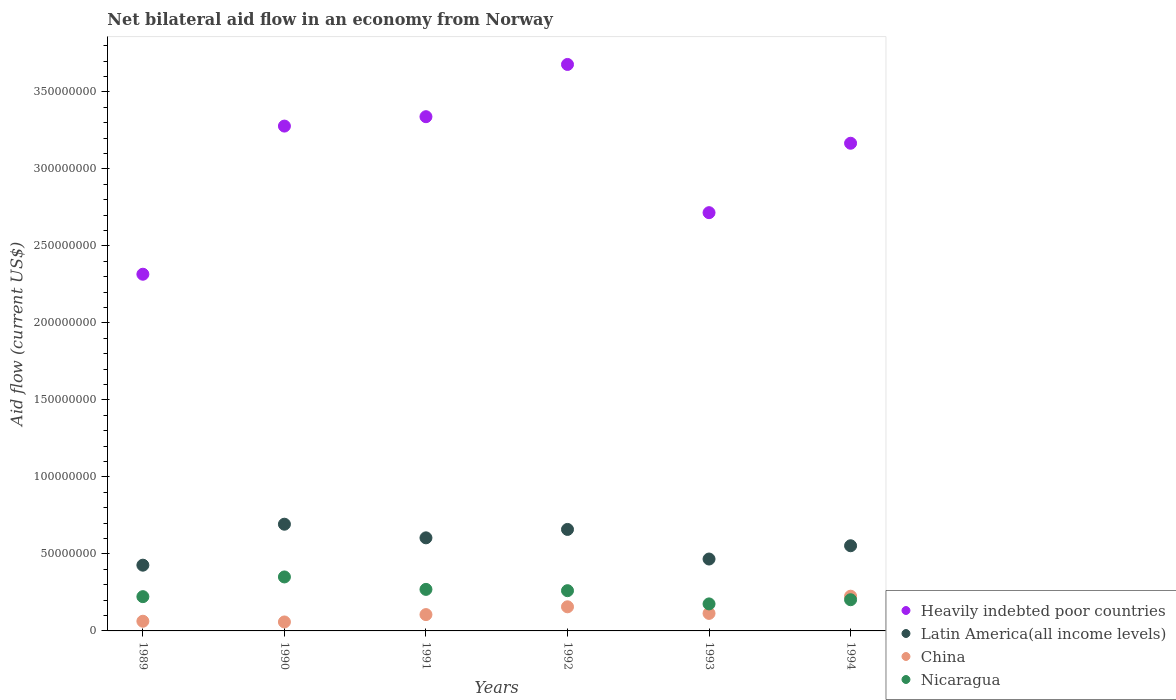Is the number of dotlines equal to the number of legend labels?
Offer a terse response. Yes. What is the net bilateral aid flow in Nicaragua in 1994?
Your answer should be compact. 2.02e+07. Across all years, what is the maximum net bilateral aid flow in Heavily indebted poor countries?
Make the answer very short. 3.68e+08. Across all years, what is the minimum net bilateral aid flow in Nicaragua?
Your answer should be very brief. 1.75e+07. In which year was the net bilateral aid flow in Latin America(all income levels) minimum?
Keep it short and to the point. 1989. What is the total net bilateral aid flow in Latin America(all income levels) in the graph?
Your answer should be compact. 3.40e+08. What is the difference between the net bilateral aid flow in China in 1990 and that in 1992?
Provide a succinct answer. -9.84e+06. What is the difference between the net bilateral aid flow in Heavily indebted poor countries in 1989 and the net bilateral aid flow in China in 1990?
Keep it short and to the point. 2.26e+08. What is the average net bilateral aid flow in China per year?
Make the answer very short. 1.20e+07. In the year 1991, what is the difference between the net bilateral aid flow in Nicaragua and net bilateral aid flow in Latin America(all income levels)?
Give a very brief answer. -3.35e+07. What is the ratio of the net bilateral aid flow in Latin America(all income levels) in 1991 to that in 1994?
Your answer should be compact. 1.09. What is the difference between the highest and the second highest net bilateral aid flow in China?
Offer a very short reply. 6.89e+06. What is the difference between the highest and the lowest net bilateral aid flow in Heavily indebted poor countries?
Ensure brevity in your answer.  1.36e+08. Does the net bilateral aid flow in Nicaragua monotonically increase over the years?
Ensure brevity in your answer.  No. Is the net bilateral aid flow in Heavily indebted poor countries strictly greater than the net bilateral aid flow in China over the years?
Your response must be concise. Yes. Is the net bilateral aid flow in Heavily indebted poor countries strictly less than the net bilateral aid flow in China over the years?
Offer a very short reply. No. How many dotlines are there?
Your answer should be very brief. 4. How many years are there in the graph?
Offer a very short reply. 6. Does the graph contain any zero values?
Provide a short and direct response. No. Does the graph contain grids?
Ensure brevity in your answer.  No. Where does the legend appear in the graph?
Your answer should be compact. Bottom right. How many legend labels are there?
Give a very brief answer. 4. How are the legend labels stacked?
Your answer should be very brief. Vertical. What is the title of the graph?
Provide a short and direct response. Net bilateral aid flow in an economy from Norway. What is the label or title of the X-axis?
Your answer should be very brief. Years. What is the label or title of the Y-axis?
Your answer should be very brief. Aid flow (current US$). What is the Aid flow (current US$) in Heavily indebted poor countries in 1989?
Give a very brief answer. 2.32e+08. What is the Aid flow (current US$) in Latin America(all income levels) in 1989?
Your response must be concise. 4.27e+07. What is the Aid flow (current US$) in China in 1989?
Keep it short and to the point. 6.28e+06. What is the Aid flow (current US$) in Nicaragua in 1989?
Provide a short and direct response. 2.22e+07. What is the Aid flow (current US$) of Heavily indebted poor countries in 1990?
Offer a terse response. 3.28e+08. What is the Aid flow (current US$) of Latin America(all income levels) in 1990?
Offer a terse response. 6.93e+07. What is the Aid flow (current US$) in China in 1990?
Your response must be concise. 5.82e+06. What is the Aid flow (current US$) of Nicaragua in 1990?
Your answer should be very brief. 3.50e+07. What is the Aid flow (current US$) in Heavily indebted poor countries in 1991?
Your answer should be very brief. 3.34e+08. What is the Aid flow (current US$) in Latin America(all income levels) in 1991?
Offer a very short reply. 6.04e+07. What is the Aid flow (current US$) in China in 1991?
Offer a terse response. 1.06e+07. What is the Aid flow (current US$) in Nicaragua in 1991?
Offer a very short reply. 2.70e+07. What is the Aid flow (current US$) of Heavily indebted poor countries in 1992?
Give a very brief answer. 3.68e+08. What is the Aid flow (current US$) of Latin America(all income levels) in 1992?
Offer a very short reply. 6.59e+07. What is the Aid flow (current US$) in China in 1992?
Your answer should be compact. 1.57e+07. What is the Aid flow (current US$) in Nicaragua in 1992?
Your answer should be very brief. 2.61e+07. What is the Aid flow (current US$) in Heavily indebted poor countries in 1993?
Make the answer very short. 2.72e+08. What is the Aid flow (current US$) in Latin America(all income levels) in 1993?
Provide a succinct answer. 4.67e+07. What is the Aid flow (current US$) of China in 1993?
Keep it short and to the point. 1.14e+07. What is the Aid flow (current US$) in Nicaragua in 1993?
Your response must be concise. 1.75e+07. What is the Aid flow (current US$) in Heavily indebted poor countries in 1994?
Offer a very short reply. 3.17e+08. What is the Aid flow (current US$) of Latin America(all income levels) in 1994?
Keep it short and to the point. 5.53e+07. What is the Aid flow (current US$) in China in 1994?
Your answer should be compact. 2.26e+07. What is the Aid flow (current US$) in Nicaragua in 1994?
Make the answer very short. 2.02e+07. Across all years, what is the maximum Aid flow (current US$) of Heavily indebted poor countries?
Provide a short and direct response. 3.68e+08. Across all years, what is the maximum Aid flow (current US$) in Latin America(all income levels)?
Your answer should be very brief. 6.93e+07. Across all years, what is the maximum Aid flow (current US$) of China?
Offer a terse response. 2.26e+07. Across all years, what is the maximum Aid flow (current US$) of Nicaragua?
Your answer should be compact. 3.50e+07. Across all years, what is the minimum Aid flow (current US$) of Heavily indebted poor countries?
Provide a short and direct response. 2.32e+08. Across all years, what is the minimum Aid flow (current US$) of Latin America(all income levels)?
Provide a succinct answer. 4.27e+07. Across all years, what is the minimum Aid flow (current US$) of China?
Keep it short and to the point. 5.82e+06. Across all years, what is the minimum Aid flow (current US$) of Nicaragua?
Offer a terse response. 1.75e+07. What is the total Aid flow (current US$) in Heavily indebted poor countries in the graph?
Give a very brief answer. 1.85e+09. What is the total Aid flow (current US$) of Latin America(all income levels) in the graph?
Your response must be concise. 3.40e+08. What is the total Aid flow (current US$) in China in the graph?
Make the answer very short. 7.23e+07. What is the total Aid flow (current US$) in Nicaragua in the graph?
Your answer should be compact. 1.48e+08. What is the difference between the Aid flow (current US$) of Heavily indebted poor countries in 1989 and that in 1990?
Provide a short and direct response. -9.62e+07. What is the difference between the Aid flow (current US$) of Latin America(all income levels) in 1989 and that in 1990?
Ensure brevity in your answer.  -2.66e+07. What is the difference between the Aid flow (current US$) in Nicaragua in 1989 and that in 1990?
Provide a succinct answer. -1.28e+07. What is the difference between the Aid flow (current US$) of Heavily indebted poor countries in 1989 and that in 1991?
Your answer should be compact. -1.02e+08. What is the difference between the Aid flow (current US$) in Latin America(all income levels) in 1989 and that in 1991?
Provide a short and direct response. -1.78e+07. What is the difference between the Aid flow (current US$) in China in 1989 and that in 1991?
Make the answer very short. -4.32e+06. What is the difference between the Aid flow (current US$) in Nicaragua in 1989 and that in 1991?
Give a very brief answer. -4.72e+06. What is the difference between the Aid flow (current US$) of Heavily indebted poor countries in 1989 and that in 1992?
Make the answer very short. -1.36e+08. What is the difference between the Aid flow (current US$) in Latin America(all income levels) in 1989 and that in 1992?
Your answer should be very brief. -2.32e+07. What is the difference between the Aid flow (current US$) of China in 1989 and that in 1992?
Make the answer very short. -9.38e+06. What is the difference between the Aid flow (current US$) of Nicaragua in 1989 and that in 1992?
Provide a succinct answer. -3.88e+06. What is the difference between the Aid flow (current US$) in Heavily indebted poor countries in 1989 and that in 1993?
Keep it short and to the point. -4.00e+07. What is the difference between the Aid flow (current US$) of Latin America(all income levels) in 1989 and that in 1993?
Your response must be concise. -3.99e+06. What is the difference between the Aid flow (current US$) in China in 1989 and that in 1993?
Your answer should be very brief. -5.09e+06. What is the difference between the Aid flow (current US$) in Nicaragua in 1989 and that in 1993?
Your response must be concise. 4.71e+06. What is the difference between the Aid flow (current US$) in Heavily indebted poor countries in 1989 and that in 1994?
Keep it short and to the point. -8.50e+07. What is the difference between the Aid flow (current US$) of Latin America(all income levels) in 1989 and that in 1994?
Your answer should be very brief. -1.26e+07. What is the difference between the Aid flow (current US$) in China in 1989 and that in 1994?
Your answer should be very brief. -1.63e+07. What is the difference between the Aid flow (current US$) in Heavily indebted poor countries in 1990 and that in 1991?
Ensure brevity in your answer.  -6.10e+06. What is the difference between the Aid flow (current US$) in Latin America(all income levels) in 1990 and that in 1991?
Keep it short and to the point. 8.85e+06. What is the difference between the Aid flow (current US$) in China in 1990 and that in 1991?
Ensure brevity in your answer.  -4.78e+06. What is the difference between the Aid flow (current US$) of Nicaragua in 1990 and that in 1991?
Provide a succinct answer. 8.08e+06. What is the difference between the Aid flow (current US$) of Heavily indebted poor countries in 1990 and that in 1992?
Keep it short and to the point. -4.00e+07. What is the difference between the Aid flow (current US$) of Latin America(all income levels) in 1990 and that in 1992?
Give a very brief answer. 3.39e+06. What is the difference between the Aid flow (current US$) in China in 1990 and that in 1992?
Offer a very short reply. -9.84e+06. What is the difference between the Aid flow (current US$) in Nicaragua in 1990 and that in 1992?
Your response must be concise. 8.92e+06. What is the difference between the Aid flow (current US$) in Heavily indebted poor countries in 1990 and that in 1993?
Give a very brief answer. 5.62e+07. What is the difference between the Aid flow (current US$) of Latin America(all income levels) in 1990 and that in 1993?
Your answer should be compact. 2.26e+07. What is the difference between the Aid flow (current US$) in China in 1990 and that in 1993?
Make the answer very short. -5.55e+06. What is the difference between the Aid flow (current US$) in Nicaragua in 1990 and that in 1993?
Make the answer very short. 1.75e+07. What is the difference between the Aid flow (current US$) of Heavily indebted poor countries in 1990 and that in 1994?
Provide a short and direct response. 1.11e+07. What is the difference between the Aid flow (current US$) of Latin America(all income levels) in 1990 and that in 1994?
Provide a succinct answer. 1.40e+07. What is the difference between the Aid flow (current US$) in China in 1990 and that in 1994?
Keep it short and to the point. -1.67e+07. What is the difference between the Aid flow (current US$) of Nicaragua in 1990 and that in 1994?
Give a very brief answer. 1.48e+07. What is the difference between the Aid flow (current US$) of Heavily indebted poor countries in 1991 and that in 1992?
Your answer should be very brief. -3.39e+07. What is the difference between the Aid flow (current US$) in Latin America(all income levels) in 1991 and that in 1992?
Your answer should be compact. -5.46e+06. What is the difference between the Aid flow (current US$) of China in 1991 and that in 1992?
Provide a short and direct response. -5.06e+06. What is the difference between the Aid flow (current US$) in Nicaragua in 1991 and that in 1992?
Your response must be concise. 8.40e+05. What is the difference between the Aid flow (current US$) in Heavily indebted poor countries in 1991 and that in 1993?
Your answer should be very brief. 6.23e+07. What is the difference between the Aid flow (current US$) of Latin America(all income levels) in 1991 and that in 1993?
Provide a short and direct response. 1.38e+07. What is the difference between the Aid flow (current US$) in China in 1991 and that in 1993?
Provide a succinct answer. -7.70e+05. What is the difference between the Aid flow (current US$) in Nicaragua in 1991 and that in 1993?
Make the answer very short. 9.43e+06. What is the difference between the Aid flow (current US$) of Heavily indebted poor countries in 1991 and that in 1994?
Your response must be concise. 1.72e+07. What is the difference between the Aid flow (current US$) of Latin America(all income levels) in 1991 and that in 1994?
Ensure brevity in your answer.  5.14e+06. What is the difference between the Aid flow (current US$) of China in 1991 and that in 1994?
Your answer should be very brief. -1.20e+07. What is the difference between the Aid flow (current US$) of Nicaragua in 1991 and that in 1994?
Give a very brief answer. 6.72e+06. What is the difference between the Aid flow (current US$) in Heavily indebted poor countries in 1992 and that in 1993?
Provide a short and direct response. 9.62e+07. What is the difference between the Aid flow (current US$) in Latin America(all income levels) in 1992 and that in 1993?
Ensure brevity in your answer.  1.92e+07. What is the difference between the Aid flow (current US$) of China in 1992 and that in 1993?
Provide a short and direct response. 4.29e+06. What is the difference between the Aid flow (current US$) in Nicaragua in 1992 and that in 1993?
Offer a very short reply. 8.59e+06. What is the difference between the Aid flow (current US$) in Heavily indebted poor countries in 1992 and that in 1994?
Your answer should be very brief. 5.12e+07. What is the difference between the Aid flow (current US$) of Latin America(all income levels) in 1992 and that in 1994?
Offer a terse response. 1.06e+07. What is the difference between the Aid flow (current US$) in China in 1992 and that in 1994?
Offer a terse response. -6.89e+06. What is the difference between the Aid flow (current US$) of Nicaragua in 1992 and that in 1994?
Your response must be concise. 5.88e+06. What is the difference between the Aid flow (current US$) of Heavily indebted poor countries in 1993 and that in 1994?
Your answer should be compact. -4.51e+07. What is the difference between the Aid flow (current US$) in Latin America(all income levels) in 1993 and that in 1994?
Provide a short and direct response. -8.62e+06. What is the difference between the Aid flow (current US$) of China in 1993 and that in 1994?
Ensure brevity in your answer.  -1.12e+07. What is the difference between the Aid flow (current US$) of Nicaragua in 1993 and that in 1994?
Offer a terse response. -2.71e+06. What is the difference between the Aid flow (current US$) of Heavily indebted poor countries in 1989 and the Aid flow (current US$) of Latin America(all income levels) in 1990?
Make the answer very short. 1.62e+08. What is the difference between the Aid flow (current US$) in Heavily indebted poor countries in 1989 and the Aid flow (current US$) in China in 1990?
Your answer should be very brief. 2.26e+08. What is the difference between the Aid flow (current US$) in Heavily indebted poor countries in 1989 and the Aid flow (current US$) in Nicaragua in 1990?
Provide a short and direct response. 1.97e+08. What is the difference between the Aid flow (current US$) of Latin America(all income levels) in 1989 and the Aid flow (current US$) of China in 1990?
Keep it short and to the point. 3.69e+07. What is the difference between the Aid flow (current US$) of Latin America(all income levels) in 1989 and the Aid flow (current US$) of Nicaragua in 1990?
Your answer should be compact. 7.64e+06. What is the difference between the Aid flow (current US$) in China in 1989 and the Aid flow (current US$) in Nicaragua in 1990?
Your response must be concise. -2.88e+07. What is the difference between the Aid flow (current US$) of Heavily indebted poor countries in 1989 and the Aid flow (current US$) of Latin America(all income levels) in 1991?
Your answer should be compact. 1.71e+08. What is the difference between the Aid flow (current US$) of Heavily indebted poor countries in 1989 and the Aid flow (current US$) of China in 1991?
Provide a short and direct response. 2.21e+08. What is the difference between the Aid flow (current US$) in Heavily indebted poor countries in 1989 and the Aid flow (current US$) in Nicaragua in 1991?
Provide a succinct answer. 2.05e+08. What is the difference between the Aid flow (current US$) in Latin America(all income levels) in 1989 and the Aid flow (current US$) in China in 1991?
Offer a terse response. 3.21e+07. What is the difference between the Aid flow (current US$) of Latin America(all income levels) in 1989 and the Aid flow (current US$) of Nicaragua in 1991?
Offer a terse response. 1.57e+07. What is the difference between the Aid flow (current US$) in China in 1989 and the Aid flow (current US$) in Nicaragua in 1991?
Provide a succinct answer. -2.07e+07. What is the difference between the Aid flow (current US$) in Heavily indebted poor countries in 1989 and the Aid flow (current US$) in Latin America(all income levels) in 1992?
Provide a succinct answer. 1.66e+08. What is the difference between the Aid flow (current US$) of Heavily indebted poor countries in 1989 and the Aid flow (current US$) of China in 1992?
Provide a succinct answer. 2.16e+08. What is the difference between the Aid flow (current US$) of Heavily indebted poor countries in 1989 and the Aid flow (current US$) of Nicaragua in 1992?
Your response must be concise. 2.05e+08. What is the difference between the Aid flow (current US$) of Latin America(all income levels) in 1989 and the Aid flow (current US$) of China in 1992?
Offer a terse response. 2.70e+07. What is the difference between the Aid flow (current US$) in Latin America(all income levels) in 1989 and the Aid flow (current US$) in Nicaragua in 1992?
Offer a very short reply. 1.66e+07. What is the difference between the Aid flow (current US$) of China in 1989 and the Aid flow (current US$) of Nicaragua in 1992?
Provide a short and direct response. -1.98e+07. What is the difference between the Aid flow (current US$) of Heavily indebted poor countries in 1989 and the Aid flow (current US$) of Latin America(all income levels) in 1993?
Your answer should be compact. 1.85e+08. What is the difference between the Aid flow (current US$) in Heavily indebted poor countries in 1989 and the Aid flow (current US$) in China in 1993?
Offer a very short reply. 2.20e+08. What is the difference between the Aid flow (current US$) in Heavily indebted poor countries in 1989 and the Aid flow (current US$) in Nicaragua in 1993?
Give a very brief answer. 2.14e+08. What is the difference between the Aid flow (current US$) of Latin America(all income levels) in 1989 and the Aid flow (current US$) of China in 1993?
Ensure brevity in your answer.  3.13e+07. What is the difference between the Aid flow (current US$) of Latin America(all income levels) in 1989 and the Aid flow (current US$) of Nicaragua in 1993?
Ensure brevity in your answer.  2.52e+07. What is the difference between the Aid flow (current US$) of China in 1989 and the Aid flow (current US$) of Nicaragua in 1993?
Your answer should be compact. -1.13e+07. What is the difference between the Aid flow (current US$) of Heavily indebted poor countries in 1989 and the Aid flow (current US$) of Latin America(all income levels) in 1994?
Keep it short and to the point. 1.76e+08. What is the difference between the Aid flow (current US$) in Heavily indebted poor countries in 1989 and the Aid flow (current US$) in China in 1994?
Keep it short and to the point. 2.09e+08. What is the difference between the Aid flow (current US$) of Heavily indebted poor countries in 1989 and the Aid flow (current US$) of Nicaragua in 1994?
Offer a terse response. 2.11e+08. What is the difference between the Aid flow (current US$) of Latin America(all income levels) in 1989 and the Aid flow (current US$) of China in 1994?
Keep it short and to the point. 2.01e+07. What is the difference between the Aid flow (current US$) in Latin America(all income levels) in 1989 and the Aid flow (current US$) in Nicaragua in 1994?
Give a very brief answer. 2.24e+07. What is the difference between the Aid flow (current US$) in China in 1989 and the Aid flow (current US$) in Nicaragua in 1994?
Keep it short and to the point. -1.40e+07. What is the difference between the Aid flow (current US$) of Heavily indebted poor countries in 1990 and the Aid flow (current US$) of Latin America(all income levels) in 1991?
Offer a very short reply. 2.67e+08. What is the difference between the Aid flow (current US$) in Heavily indebted poor countries in 1990 and the Aid flow (current US$) in China in 1991?
Offer a terse response. 3.17e+08. What is the difference between the Aid flow (current US$) of Heavily indebted poor countries in 1990 and the Aid flow (current US$) of Nicaragua in 1991?
Your answer should be very brief. 3.01e+08. What is the difference between the Aid flow (current US$) of Latin America(all income levels) in 1990 and the Aid flow (current US$) of China in 1991?
Keep it short and to the point. 5.87e+07. What is the difference between the Aid flow (current US$) in Latin America(all income levels) in 1990 and the Aid flow (current US$) in Nicaragua in 1991?
Your response must be concise. 4.23e+07. What is the difference between the Aid flow (current US$) of China in 1990 and the Aid flow (current US$) of Nicaragua in 1991?
Provide a succinct answer. -2.12e+07. What is the difference between the Aid flow (current US$) in Heavily indebted poor countries in 1990 and the Aid flow (current US$) in Latin America(all income levels) in 1992?
Your response must be concise. 2.62e+08. What is the difference between the Aid flow (current US$) of Heavily indebted poor countries in 1990 and the Aid flow (current US$) of China in 1992?
Provide a short and direct response. 3.12e+08. What is the difference between the Aid flow (current US$) in Heavily indebted poor countries in 1990 and the Aid flow (current US$) in Nicaragua in 1992?
Your response must be concise. 3.02e+08. What is the difference between the Aid flow (current US$) in Latin America(all income levels) in 1990 and the Aid flow (current US$) in China in 1992?
Provide a short and direct response. 5.36e+07. What is the difference between the Aid flow (current US$) of Latin America(all income levels) in 1990 and the Aid flow (current US$) of Nicaragua in 1992?
Give a very brief answer. 4.32e+07. What is the difference between the Aid flow (current US$) in China in 1990 and the Aid flow (current US$) in Nicaragua in 1992?
Ensure brevity in your answer.  -2.03e+07. What is the difference between the Aid flow (current US$) in Heavily indebted poor countries in 1990 and the Aid flow (current US$) in Latin America(all income levels) in 1993?
Your answer should be compact. 2.81e+08. What is the difference between the Aid flow (current US$) of Heavily indebted poor countries in 1990 and the Aid flow (current US$) of China in 1993?
Keep it short and to the point. 3.16e+08. What is the difference between the Aid flow (current US$) of Heavily indebted poor countries in 1990 and the Aid flow (current US$) of Nicaragua in 1993?
Give a very brief answer. 3.10e+08. What is the difference between the Aid flow (current US$) of Latin America(all income levels) in 1990 and the Aid flow (current US$) of China in 1993?
Give a very brief answer. 5.79e+07. What is the difference between the Aid flow (current US$) of Latin America(all income levels) in 1990 and the Aid flow (current US$) of Nicaragua in 1993?
Make the answer very short. 5.18e+07. What is the difference between the Aid flow (current US$) of China in 1990 and the Aid flow (current US$) of Nicaragua in 1993?
Provide a succinct answer. -1.17e+07. What is the difference between the Aid flow (current US$) of Heavily indebted poor countries in 1990 and the Aid flow (current US$) of Latin America(all income levels) in 1994?
Offer a terse response. 2.72e+08. What is the difference between the Aid flow (current US$) in Heavily indebted poor countries in 1990 and the Aid flow (current US$) in China in 1994?
Provide a succinct answer. 3.05e+08. What is the difference between the Aid flow (current US$) of Heavily indebted poor countries in 1990 and the Aid flow (current US$) of Nicaragua in 1994?
Offer a terse response. 3.08e+08. What is the difference between the Aid flow (current US$) in Latin America(all income levels) in 1990 and the Aid flow (current US$) in China in 1994?
Ensure brevity in your answer.  4.67e+07. What is the difference between the Aid flow (current US$) in Latin America(all income levels) in 1990 and the Aid flow (current US$) in Nicaragua in 1994?
Your answer should be compact. 4.90e+07. What is the difference between the Aid flow (current US$) in China in 1990 and the Aid flow (current US$) in Nicaragua in 1994?
Your answer should be very brief. -1.44e+07. What is the difference between the Aid flow (current US$) of Heavily indebted poor countries in 1991 and the Aid flow (current US$) of Latin America(all income levels) in 1992?
Keep it short and to the point. 2.68e+08. What is the difference between the Aid flow (current US$) of Heavily indebted poor countries in 1991 and the Aid flow (current US$) of China in 1992?
Ensure brevity in your answer.  3.18e+08. What is the difference between the Aid flow (current US$) of Heavily indebted poor countries in 1991 and the Aid flow (current US$) of Nicaragua in 1992?
Offer a terse response. 3.08e+08. What is the difference between the Aid flow (current US$) in Latin America(all income levels) in 1991 and the Aid flow (current US$) in China in 1992?
Make the answer very short. 4.48e+07. What is the difference between the Aid flow (current US$) in Latin America(all income levels) in 1991 and the Aid flow (current US$) in Nicaragua in 1992?
Your answer should be very brief. 3.43e+07. What is the difference between the Aid flow (current US$) in China in 1991 and the Aid flow (current US$) in Nicaragua in 1992?
Your response must be concise. -1.55e+07. What is the difference between the Aid flow (current US$) of Heavily indebted poor countries in 1991 and the Aid flow (current US$) of Latin America(all income levels) in 1993?
Offer a terse response. 2.87e+08. What is the difference between the Aid flow (current US$) of Heavily indebted poor countries in 1991 and the Aid flow (current US$) of China in 1993?
Offer a terse response. 3.23e+08. What is the difference between the Aid flow (current US$) of Heavily indebted poor countries in 1991 and the Aid flow (current US$) of Nicaragua in 1993?
Provide a short and direct response. 3.16e+08. What is the difference between the Aid flow (current US$) in Latin America(all income levels) in 1991 and the Aid flow (current US$) in China in 1993?
Keep it short and to the point. 4.91e+07. What is the difference between the Aid flow (current US$) in Latin America(all income levels) in 1991 and the Aid flow (current US$) in Nicaragua in 1993?
Your response must be concise. 4.29e+07. What is the difference between the Aid flow (current US$) of China in 1991 and the Aid flow (current US$) of Nicaragua in 1993?
Keep it short and to the point. -6.94e+06. What is the difference between the Aid flow (current US$) of Heavily indebted poor countries in 1991 and the Aid flow (current US$) of Latin America(all income levels) in 1994?
Make the answer very short. 2.79e+08. What is the difference between the Aid flow (current US$) in Heavily indebted poor countries in 1991 and the Aid flow (current US$) in China in 1994?
Your answer should be very brief. 3.11e+08. What is the difference between the Aid flow (current US$) in Heavily indebted poor countries in 1991 and the Aid flow (current US$) in Nicaragua in 1994?
Provide a succinct answer. 3.14e+08. What is the difference between the Aid flow (current US$) in Latin America(all income levels) in 1991 and the Aid flow (current US$) in China in 1994?
Your answer should be compact. 3.79e+07. What is the difference between the Aid flow (current US$) of Latin America(all income levels) in 1991 and the Aid flow (current US$) of Nicaragua in 1994?
Make the answer very short. 4.02e+07. What is the difference between the Aid flow (current US$) of China in 1991 and the Aid flow (current US$) of Nicaragua in 1994?
Your response must be concise. -9.65e+06. What is the difference between the Aid flow (current US$) of Heavily indebted poor countries in 1992 and the Aid flow (current US$) of Latin America(all income levels) in 1993?
Offer a very short reply. 3.21e+08. What is the difference between the Aid flow (current US$) in Heavily indebted poor countries in 1992 and the Aid flow (current US$) in China in 1993?
Provide a succinct answer. 3.56e+08. What is the difference between the Aid flow (current US$) in Heavily indebted poor countries in 1992 and the Aid flow (current US$) in Nicaragua in 1993?
Keep it short and to the point. 3.50e+08. What is the difference between the Aid flow (current US$) of Latin America(all income levels) in 1992 and the Aid flow (current US$) of China in 1993?
Your answer should be compact. 5.45e+07. What is the difference between the Aid flow (current US$) in Latin America(all income levels) in 1992 and the Aid flow (current US$) in Nicaragua in 1993?
Your answer should be compact. 4.84e+07. What is the difference between the Aid flow (current US$) of China in 1992 and the Aid flow (current US$) of Nicaragua in 1993?
Offer a terse response. -1.88e+06. What is the difference between the Aid flow (current US$) in Heavily indebted poor countries in 1992 and the Aid flow (current US$) in Latin America(all income levels) in 1994?
Make the answer very short. 3.13e+08. What is the difference between the Aid flow (current US$) of Heavily indebted poor countries in 1992 and the Aid flow (current US$) of China in 1994?
Make the answer very short. 3.45e+08. What is the difference between the Aid flow (current US$) in Heavily indebted poor countries in 1992 and the Aid flow (current US$) in Nicaragua in 1994?
Offer a terse response. 3.48e+08. What is the difference between the Aid flow (current US$) in Latin America(all income levels) in 1992 and the Aid flow (current US$) in China in 1994?
Ensure brevity in your answer.  4.34e+07. What is the difference between the Aid flow (current US$) in Latin America(all income levels) in 1992 and the Aid flow (current US$) in Nicaragua in 1994?
Offer a very short reply. 4.56e+07. What is the difference between the Aid flow (current US$) of China in 1992 and the Aid flow (current US$) of Nicaragua in 1994?
Provide a succinct answer. -4.59e+06. What is the difference between the Aid flow (current US$) of Heavily indebted poor countries in 1993 and the Aid flow (current US$) of Latin America(all income levels) in 1994?
Make the answer very short. 2.16e+08. What is the difference between the Aid flow (current US$) of Heavily indebted poor countries in 1993 and the Aid flow (current US$) of China in 1994?
Give a very brief answer. 2.49e+08. What is the difference between the Aid flow (current US$) of Heavily indebted poor countries in 1993 and the Aid flow (current US$) of Nicaragua in 1994?
Give a very brief answer. 2.51e+08. What is the difference between the Aid flow (current US$) of Latin America(all income levels) in 1993 and the Aid flow (current US$) of China in 1994?
Provide a short and direct response. 2.41e+07. What is the difference between the Aid flow (current US$) of Latin America(all income levels) in 1993 and the Aid flow (current US$) of Nicaragua in 1994?
Provide a succinct answer. 2.64e+07. What is the difference between the Aid flow (current US$) of China in 1993 and the Aid flow (current US$) of Nicaragua in 1994?
Provide a succinct answer. -8.88e+06. What is the average Aid flow (current US$) in Heavily indebted poor countries per year?
Your response must be concise. 3.08e+08. What is the average Aid flow (current US$) in Latin America(all income levels) per year?
Give a very brief answer. 5.67e+07. What is the average Aid flow (current US$) of China per year?
Keep it short and to the point. 1.20e+07. What is the average Aid flow (current US$) of Nicaragua per year?
Offer a very short reply. 2.47e+07. In the year 1989, what is the difference between the Aid flow (current US$) in Heavily indebted poor countries and Aid flow (current US$) in Latin America(all income levels)?
Keep it short and to the point. 1.89e+08. In the year 1989, what is the difference between the Aid flow (current US$) in Heavily indebted poor countries and Aid flow (current US$) in China?
Provide a succinct answer. 2.25e+08. In the year 1989, what is the difference between the Aid flow (current US$) of Heavily indebted poor countries and Aid flow (current US$) of Nicaragua?
Your response must be concise. 2.09e+08. In the year 1989, what is the difference between the Aid flow (current US$) of Latin America(all income levels) and Aid flow (current US$) of China?
Your answer should be compact. 3.64e+07. In the year 1989, what is the difference between the Aid flow (current US$) in Latin America(all income levels) and Aid flow (current US$) in Nicaragua?
Offer a terse response. 2.04e+07. In the year 1989, what is the difference between the Aid flow (current US$) in China and Aid flow (current US$) in Nicaragua?
Provide a short and direct response. -1.60e+07. In the year 1990, what is the difference between the Aid flow (current US$) of Heavily indebted poor countries and Aid flow (current US$) of Latin America(all income levels)?
Offer a terse response. 2.58e+08. In the year 1990, what is the difference between the Aid flow (current US$) of Heavily indebted poor countries and Aid flow (current US$) of China?
Your response must be concise. 3.22e+08. In the year 1990, what is the difference between the Aid flow (current US$) of Heavily indebted poor countries and Aid flow (current US$) of Nicaragua?
Keep it short and to the point. 2.93e+08. In the year 1990, what is the difference between the Aid flow (current US$) of Latin America(all income levels) and Aid flow (current US$) of China?
Your answer should be very brief. 6.35e+07. In the year 1990, what is the difference between the Aid flow (current US$) in Latin America(all income levels) and Aid flow (current US$) in Nicaragua?
Your answer should be compact. 3.42e+07. In the year 1990, what is the difference between the Aid flow (current US$) of China and Aid flow (current US$) of Nicaragua?
Provide a succinct answer. -2.92e+07. In the year 1991, what is the difference between the Aid flow (current US$) of Heavily indebted poor countries and Aid flow (current US$) of Latin America(all income levels)?
Make the answer very short. 2.73e+08. In the year 1991, what is the difference between the Aid flow (current US$) in Heavily indebted poor countries and Aid flow (current US$) in China?
Your answer should be very brief. 3.23e+08. In the year 1991, what is the difference between the Aid flow (current US$) of Heavily indebted poor countries and Aid flow (current US$) of Nicaragua?
Ensure brevity in your answer.  3.07e+08. In the year 1991, what is the difference between the Aid flow (current US$) in Latin America(all income levels) and Aid flow (current US$) in China?
Your response must be concise. 4.98e+07. In the year 1991, what is the difference between the Aid flow (current US$) of Latin America(all income levels) and Aid flow (current US$) of Nicaragua?
Keep it short and to the point. 3.35e+07. In the year 1991, what is the difference between the Aid flow (current US$) of China and Aid flow (current US$) of Nicaragua?
Offer a very short reply. -1.64e+07. In the year 1992, what is the difference between the Aid flow (current US$) in Heavily indebted poor countries and Aid flow (current US$) in Latin America(all income levels)?
Make the answer very short. 3.02e+08. In the year 1992, what is the difference between the Aid flow (current US$) in Heavily indebted poor countries and Aid flow (current US$) in China?
Provide a succinct answer. 3.52e+08. In the year 1992, what is the difference between the Aid flow (current US$) of Heavily indebted poor countries and Aid flow (current US$) of Nicaragua?
Ensure brevity in your answer.  3.42e+08. In the year 1992, what is the difference between the Aid flow (current US$) of Latin America(all income levels) and Aid flow (current US$) of China?
Keep it short and to the point. 5.02e+07. In the year 1992, what is the difference between the Aid flow (current US$) of Latin America(all income levels) and Aid flow (current US$) of Nicaragua?
Provide a short and direct response. 3.98e+07. In the year 1992, what is the difference between the Aid flow (current US$) of China and Aid flow (current US$) of Nicaragua?
Ensure brevity in your answer.  -1.05e+07. In the year 1993, what is the difference between the Aid flow (current US$) in Heavily indebted poor countries and Aid flow (current US$) in Latin America(all income levels)?
Make the answer very short. 2.25e+08. In the year 1993, what is the difference between the Aid flow (current US$) of Heavily indebted poor countries and Aid flow (current US$) of China?
Ensure brevity in your answer.  2.60e+08. In the year 1993, what is the difference between the Aid flow (current US$) of Heavily indebted poor countries and Aid flow (current US$) of Nicaragua?
Your response must be concise. 2.54e+08. In the year 1993, what is the difference between the Aid flow (current US$) in Latin America(all income levels) and Aid flow (current US$) in China?
Provide a succinct answer. 3.53e+07. In the year 1993, what is the difference between the Aid flow (current US$) of Latin America(all income levels) and Aid flow (current US$) of Nicaragua?
Your answer should be compact. 2.91e+07. In the year 1993, what is the difference between the Aid flow (current US$) in China and Aid flow (current US$) in Nicaragua?
Your answer should be very brief. -6.17e+06. In the year 1994, what is the difference between the Aid flow (current US$) in Heavily indebted poor countries and Aid flow (current US$) in Latin America(all income levels)?
Keep it short and to the point. 2.61e+08. In the year 1994, what is the difference between the Aid flow (current US$) in Heavily indebted poor countries and Aid flow (current US$) in China?
Offer a very short reply. 2.94e+08. In the year 1994, what is the difference between the Aid flow (current US$) in Heavily indebted poor countries and Aid flow (current US$) in Nicaragua?
Offer a very short reply. 2.96e+08. In the year 1994, what is the difference between the Aid flow (current US$) of Latin America(all income levels) and Aid flow (current US$) of China?
Offer a very short reply. 3.28e+07. In the year 1994, what is the difference between the Aid flow (current US$) of Latin America(all income levels) and Aid flow (current US$) of Nicaragua?
Offer a terse response. 3.50e+07. In the year 1994, what is the difference between the Aid flow (current US$) of China and Aid flow (current US$) of Nicaragua?
Ensure brevity in your answer.  2.30e+06. What is the ratio of the Aid flow (current US$) in Heavily indebted poor countries in 1989 to that in 1990?
Provide a succinct answer. 0.71. What is the ratio of the Aid flow (current US$) in Latin America(all income levels) in 1989 to that in 1990?
Provide a short and direct response. 0.62. What is the ratio of the Aid flow (current US$) in China in 1989 to that in 1990?
Provide a succinct answer. 1.08. What is the ratio of the Aid flow (current US$) of Nicaragua in 1989 to that in 1990?
Your response must be concise. 0.63. What is the ratio of the Aid flow (current US$) of Heavily indebted poor countries in 1989 to that in 1991?
Provide a short and direct response. 0.69. What is the ratio of the Aid flow (current US$) in Latin America(all income levels) in 1989 to that in 1991?
Ensure brevity in your answer.  0.71. What is the ratio of the Aid flow (current US$) in China in 1989 to that in 1991?
Your answer should be compact. 0.59. What is the ratio of the Aid flow (current US$) of Nicaragua in 1989 to that in 1991?
Offer a very short reply. 0.82. What is the ratio of the Aid flow (current US$) of Heavily indebted poor countries in 1989 to that in 1992?
Offer a very short reply. 0.63. What is the ratio of the Aid flow (current US$) of Latin America(all income levels) in 1989 to that in 1992?
Make the answer very short. 0.65. What is the ratio of the Aid flow (current US$) of China in 1989 to that in 1992?
Make the answer very short. 0.4. What is the ratio of the Aid flow (current US$) in Nicaragua in 1989 to that in 1992?
Provide a succinct answer. 0.85. What is the ratio of the Aid flow (current US$) in Heavily indebted poor countries in 1989 to that in 1993?
Your response must be concise. 0.85. What is the ratio of the Aid flow (current US$) of Latin America(all income levels) in 1989 to that in 1993?
Ensure brevity in your answer.  0.91. What is the ratio of the Aid flow (current US$) in China in 1989 to that in 1993?
Offer a very short reply. 0.55. What is the ratio of the Aid flow (current US$) in Nicaragua in 1989 to that in 1993?
Your answer should be compact. 1.27. What is the ratio of the Aid flow (current US$) in Heavily indebted poor countries in 1989 to that in 1994?
Provide a succinct answer. 0.73. What is the ratio of the Aid flow (current US$) in Latin America(all income levels) in 1989 to that in 1994?
Offer a very short reply. 0.77. What is the ratio of the Aid flow (current US$) of China in 1989 to that in 1994?
Offer a terse response. 0.28. What is the ratio of the Aid flow (current US$) in Nicaragua in 1989 to that in 1994?
Provide a succinct answer. 1.1. What is the ratio of the Aid flow (current US$) of Heavily indebted poor countries in 1990 to that in 1991?
Offer a terse response. 0.98. What is the ratio of the Aid flow (current US$) of Latin America(all income levels) in 1990 to that in 1991?
Your response must be concise. 1.15. What is the ratio of the Aid flow (current US$) in China in 1990 to that in 1991?
Make the answer very short. 0.55. What is the ratio of the Aid flow (current US$) in Nicaragua in 1990 to that in 1991?
Offer a terse response. 1.3. What is the ratio of the Aid flow (current US$) of Heavily indebted poor countries in 1990 to that in 1992?
Provide a short and direct response. 0.89. What is the ratio of the Aid flow (current US$) in Latin America(all income levels) in 1990 to that in 1992?
Offer a very short reply. 1.05. What is the ratio of the Aid flow (current US$) in China in 1990 to that in 1992?
Ensure brevity in your answer.  0.37. What is the ratio of the Aid flow (current US$) of Nicaragua in 1990 to that in 1992?
Ensure brevity in your answer.  1.34. What is the ratio of the Aid flow (current US$) of Heavily indebted poor countries in 1990 to that in 1993?
Provide a short and direct response. 1.21. What is the ratio of the Aid flow (current US$) of Latin America(all income levels) in 1990 to that in 1993?
Keep it short and to the point. 1.48. What is the ratio of the Aid flow (current US$) in China in 1990 to that in 1993?
Offer a very short reply. 0.51. What is the ratio of the Aid flow (current US$) of Nicaragua in 1990 to that in 1993?
Keep it short and to the point. 2. What is the ratio of the Aid flow (current US$) in Heavily indebted poor countries in 1990 to that in 1994?
Your response must be concise. 1.04. What is the ratio of the Aid flow (current US$) of Latin America(all income levels) in 1990 to that in 1994?
Make the answer very short. 1.25. What is the ratio of the Aid flow (current US$) of China in 1990 to that in 1994?
Ensure brevity in your answer.  0.26. What is the ratio of the Aid flow (current US$) in Nicaragua in 1990 to that in 1994?
Offer a very short reply. 1.73. What is the ratio of the Aid flow (current US$) in Heavily indebted poor countries in 1991 to that in 1992?
Give a very brief answer. 0.91. What is the ratio of the Aid flow (current US$) in Latin America(all income levels) in 1991 to that in 1992?
Give a very brief answer. 0.92. What is the ratio of the Aid flow (current US$) in China in 1991 to that in 1992?
Provide a succinct answer. 0.68. What is the ratio of the Aid flow (current US$) in Nicaragua in 1991 to that in 1992?
Your response must be concise. 1.03. What is the ratio of the Aid flow (current US$) in Heavily indebted poor countries in 1991 to that in 1993?
Make the answer very short. 1.23. What is the ratio of the Aid flow (current US$) of Latin America(all income levels) in 1991 to that in 1993?
Make the answer very short. 1.29. What is the ratio of the Aid flow (current US$) of China in 1991 to that in 1993?
Make the answer very short. 0.93. What is the ratio of the Aid flow (current US$) of Nicaragua in 1991 to that in 1993?
Your answer should be compact. 1.54. What is the ratio of the Aid flow (current US$) in Heavily indebted poor countries in 1991 to that in 1994?
Your answer should be compact. 1.05. What is the ratio of the Aid flow (current US$) in Latin America(all income levels) in 1991 to that in 1994?
Give a very brief answer. 1.09. What is the ratio of the Aid flow (current US$) of China in 1991 to that in 1994?
Offer a very short reply. 0.47. What is the ratio of the Aid flow (current US$) in Nicaragua in 1991 to that in 1994?
Offer a very short reply. 1.33. What is the ratio of the Aid flow (current US$) of Heavily indebted poor countries in 1992 to that in 1993?
Your answer should be very brief. 1.35. What is the ratio of the Aid flow (current US$) of Latin America(all income levels) in 1992 to that in 1993?
Offer a very short reply. 1.41. What is the ratio of the Aid flow (current US$) in China in 1992 to that in 1993?
Give a very brief answer. 1.38. What is the ratio of the Aid flow (current US$) in Nicaragua in 1992 to that in 1993?
Ensure brevity in your answer.  1.49. What is the ratio of the Aid flow (current US$) of Heavily indebted poor countries in 1992 to that in 1994?
Your response must be concise. 1.16. What is the ratio of the Aid flow (current US$) in Latin America(all income levels) in 1992 to that in 1994?
Provide a short and direct response. 1.19. What is the ratio of the Aid flow (current US$) in China in 1992 to that in 1994?
Offer a terse response. 0.69. What is the ratio of the Aid flow (current US$) in Nicaragua in 1992 to that in 1994?
Your answer should be compact. 1.29. What is the ratio of the Aid flow (current US$) of Heavily indebted poor countries in 1993 to that in 1994?
Your response must be concise. 0.86. What is the ratio of the Aid flow (current US$) in Latin America(all income levels) in 1993 to that in 1994?
Provide a short and direct response. 0.84. What is the ratio of the Aid flow (current US$) in China in 1993 to that in 1994?
Offer a very short reply. 0.5. What is the ratio of the Aid flow (current US$) of Nicaragua in 1993 to that in 1994?
Offer a very short reply. 0.87. What is the difference between the highest and the second highest Aid flow (current US$) of Heavily indebted poor countries?
Your answer should be very brief. 3.39e+07. What is the difference between the highest and the second highest Aid flow (current US$) of Latin America(all income levels)?
Offer a terse response. 3.39e+06. What is the difference between the highest and the second highest Aid flow (current US$) of China?
Make the answer very short. 6.89e+06. What is the difference between the highest and the second highest Aid flow (current US$) of Nicaragua?
Ensure brevity in your answer.  8.08e+06. What is the difference between the highest and the lowest Aid flow (current US$) in Heavily indebted poor countries?
Keep it short and to the point. 1.36e+08. What is the difference between the highest and the lowest Aid flow (current US$) in Latin America(all income levels)?
Give a very brief answer. 2.66e+07. What is the difference between the highest and the lowest Aid flow (current US$) in China?
Offer a very short reply. 1.67e+07. What is the difference between the highest and the lowest Aid flow (current US$) of Nicaragua?
Your response must be concise. 1.75e+07. 